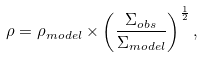<formula> <loc_0><loc_0><loc_500><loc_500>\rho = \rho _ { m o d e l } \times \left ( \frac { \Sigma _ { o b s } } { \Sigma _ { m o d e l } } \right ) ^ { \frac { 1 } { 2 } } ,</formula> 